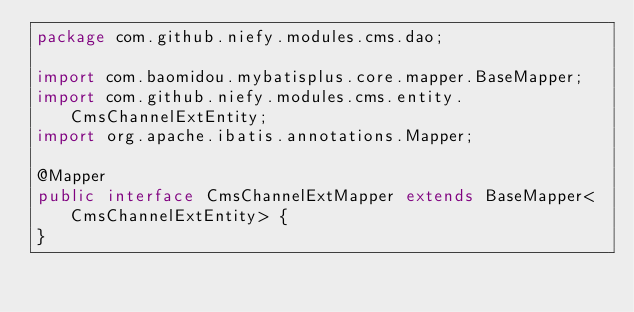Convert code to text. <code><loc_0><loc_0><loc_500><loc_500><_Java_>package com.github.niefy.modules.cms.dao;

import com.baomidou.mybatisplus.core.mapper.BaseMapper;
import com.github.niefy.modules.cms.entity.CmsChannelExtEntity;
import org.apache.ibatis.annotations.Mapper;

@Mapper
public interface CmsChannelExtMapper extends BaseMapper<CmsChannelExtEntity> {
}
</code> 